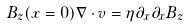<formula> <loc_0><loc_0><loc_500><loc_500>B _ { z } ( x = 0 ) \nabla \cdot { v } = \eta \partial _ { x } \partial _ { x } B _ { z }</formula> 